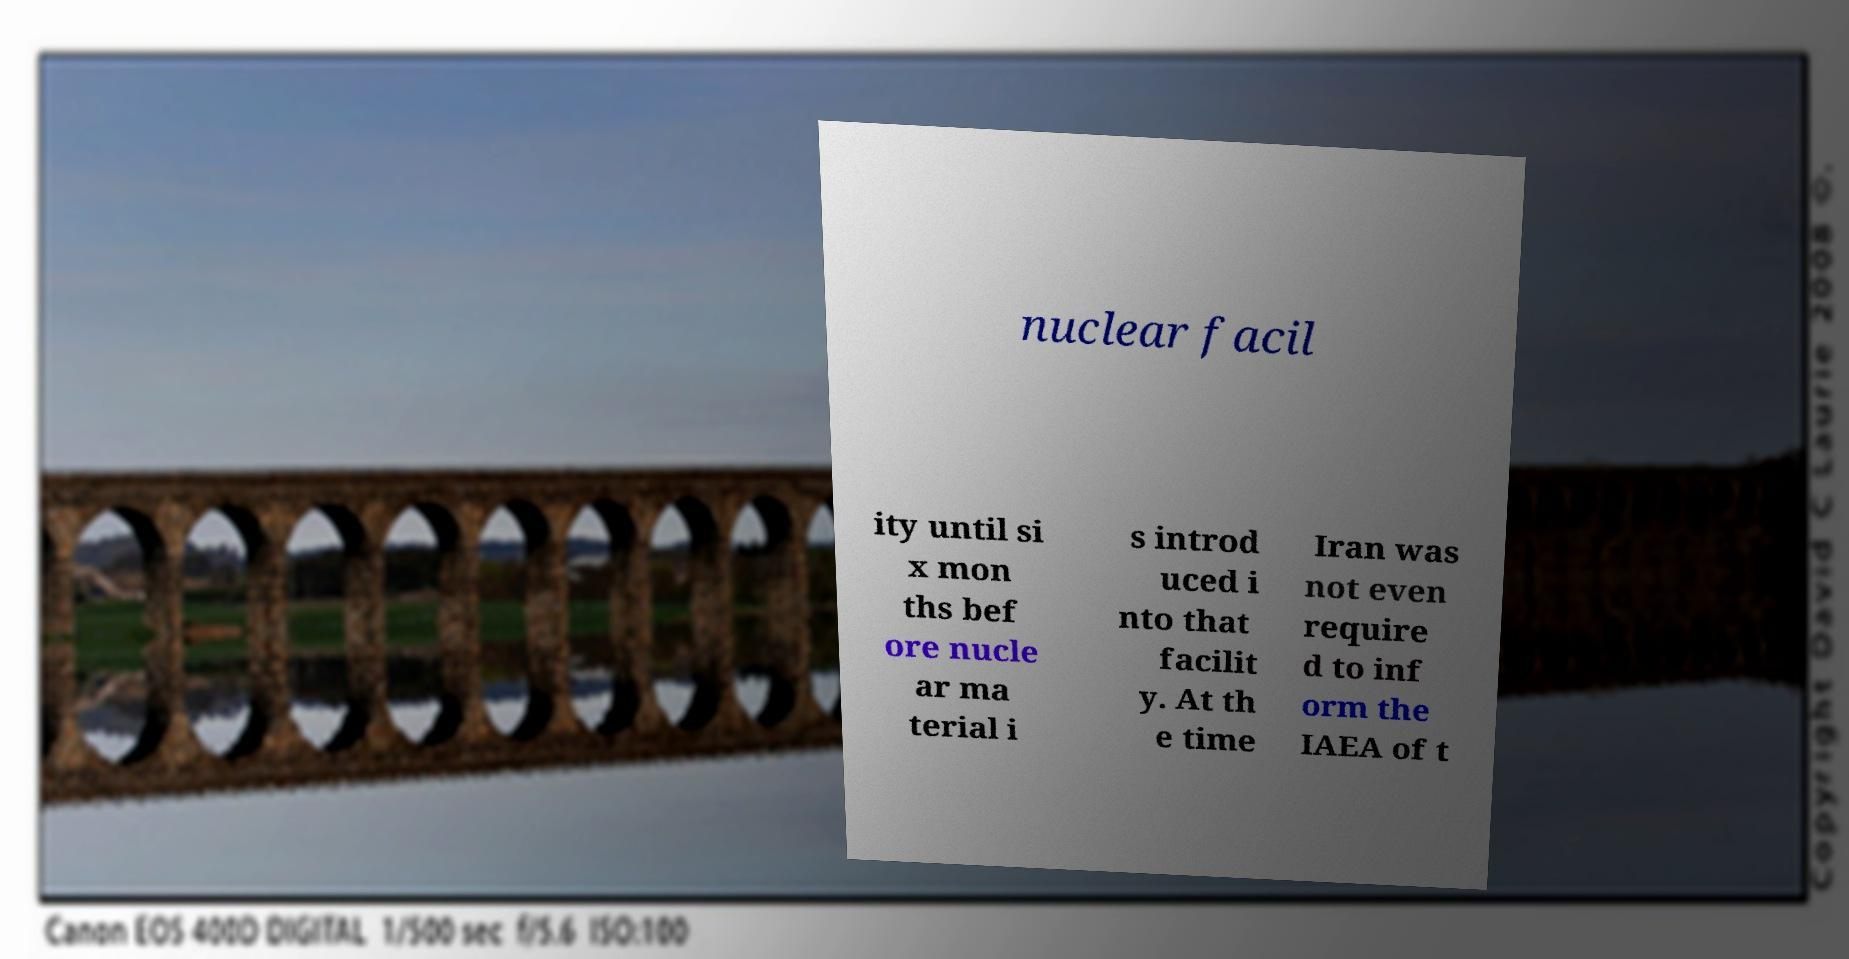Could you assist in decoding the text presented in this image and type it out clearly? nuclear facil ity until si x mon ths bef ore nucle ar ma terial i s introd uced i nto that facilit y. At th e time Iran was not even require d to inf orm the IAEA of t 